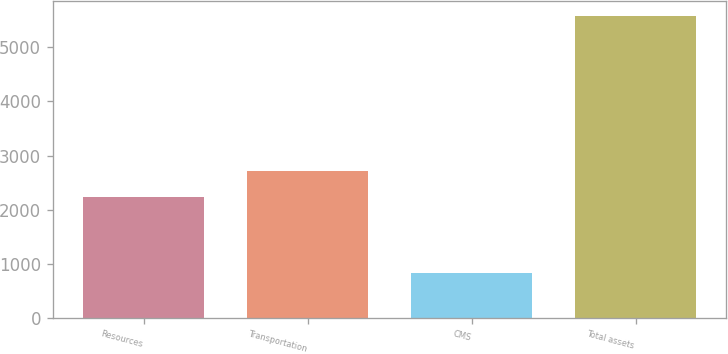Convert chart to OTSL. <chart><loc_0><loc_0><loc_500><loc_500><bar_chart><fcel>Resources<fcel>Transportation<fcel>CMS<fcel>Total assets<nl><fcel>2238.1<fcel>2712.34<fcel>835.1<fcel>5577.5<nl></chart> 